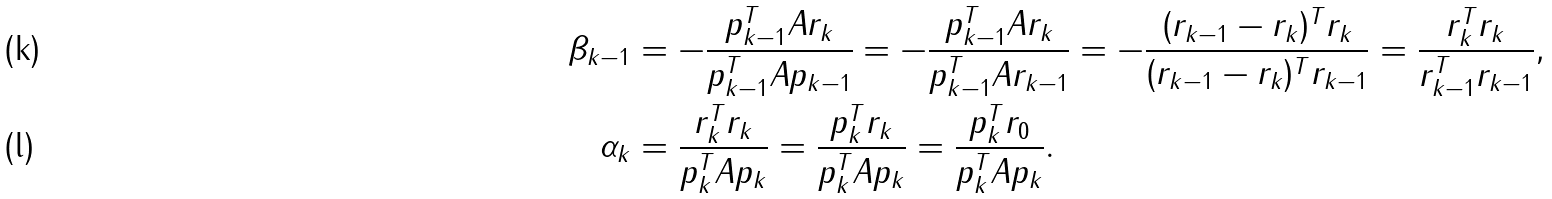Convert formula to latex. <formula><loc_0><loc_0><loc_500><loc_500>\beta _ { k - 1 } & = - \frac { p _ { k - 1 } ^ { T } A r _ { k } } { p _ { k - 1 } ^ { T } A p _ { k - 1 } } = - \frac { p _ { k - 1 } ^ { T } A r _ { k } } { p _ { k - 1 } ^ { T } A r _ { k - 1 } } = - \frac { ( r _ { k - 1 } - r _ { k } ) ^ { T } r _ { k } } { ( r _ { k - 1 } - r _ { k } ) ^ { T } r _ { k - 1 } } = \frac { r _ { k } ^ { T } r _ { k } } { r _ { k - 1 } ^ { T } r _ { k - 1 } } , \\ \alpha _ { k } & = \frac { r _ { k } ^ { T } r _ { k } } { p _ { k } ^ { T } A p _ { k } } = \frac { p _ { k } ^ { T } r _ { k } } { p _ { k } ^ { T } A p _ { k } } = \frac { p _ { k } ^ { T } r _ { 0 } } { p _ { k } ^ { T } A p _ { k } } .</formula> 